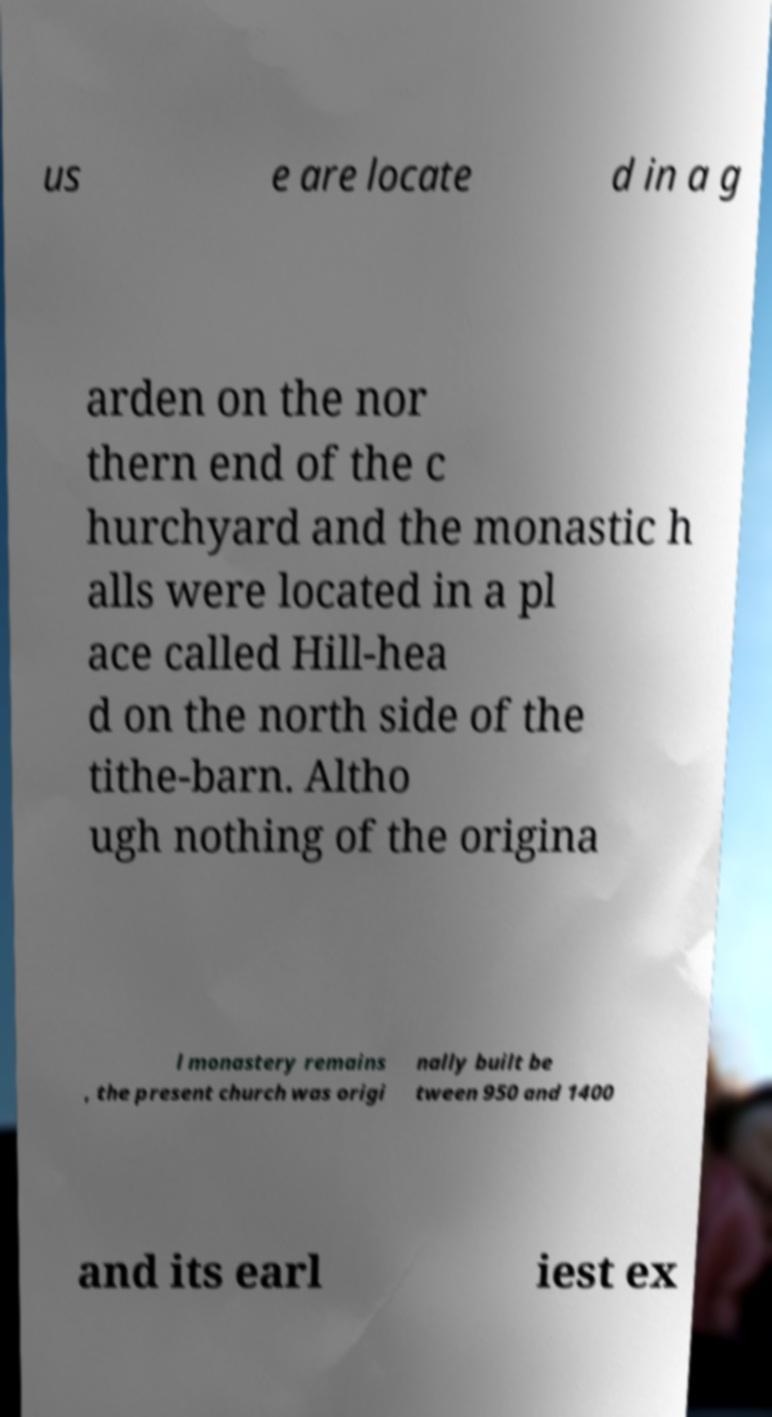Can you accurately transcribe the text from the provided image for me? us e are locate d in a g arden on the nor thern end of the c hurchyard and the monastic h alls were located in a pl ace called Hill-hea d on the north side of the tithe-barn. Altho ugh nothing of the origina l monastery remains , the present church was origi nally built be tween 950 and 1400 and its earl iest ex 